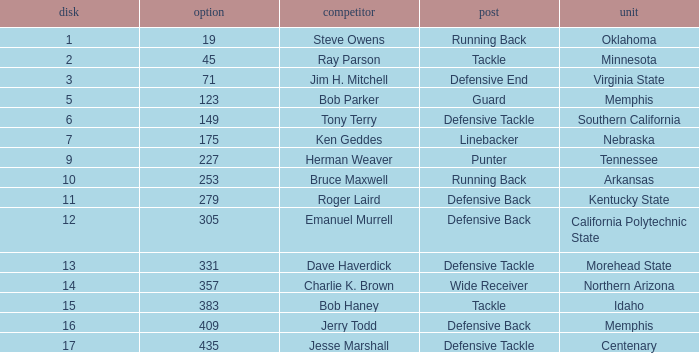What is the lowest pick of the defensive tackle player dave haverdick? 331.0. 